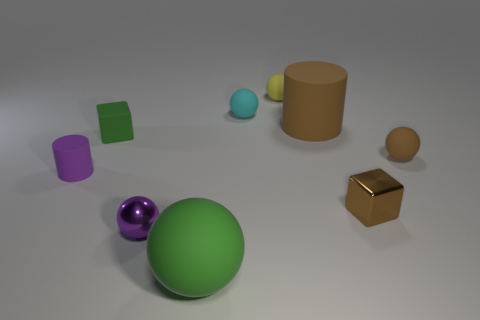How many other things are there of the same size as the brown block?
Ensure brevity in your answer.  6. How many cubes are purple objects or small purple shiny things?
Make the answer very short. 0. Are there any other things that have the same material as the green cube?
Your response must be concise. Yes. What is the material of the small block that is in front of the cube left of the large cylinder to the right of the small green rubber object?
Give a very brief answer. Metal. There is a thing that is the same color as the large ball; what material is it?
Offer a very short reply. Rubber. How many other big green balls are the same material as the green sphere?
Give a very brief answer. 0. Does the green thing behind the purple rubber cylinder have the same size as the small brown shiny block?
Provide a succinct answer. Yes. The small cylinder that is made of the same material as the tiny green thing is what color?
Offer a very short reply. Purple. How many rubber blocks are on the right side of the metal block?
Give a very brief answer. 0. There is a matte ball that is on the right side of the metal cube; is it the same color as the big rubber thing behind the purple matte cylinder?
Your response must be concise. Yes. 